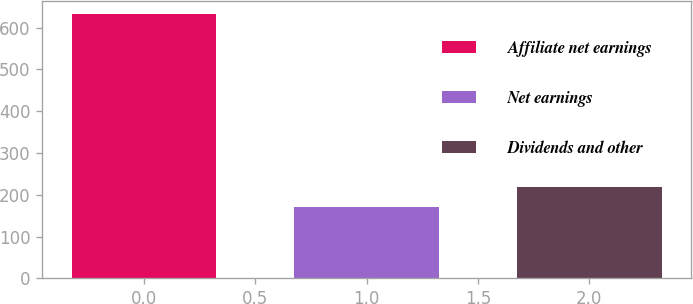Convert chart to OTSL. <chart><loc_0><loc_0><loc_500><loc_500><bar_chart><fcel>Affiliate net earnings<fcel>Net earnings<fcel>Dividends and other<nl><fcel>633<fcel>172<fcel>218.1<nl></chart> 